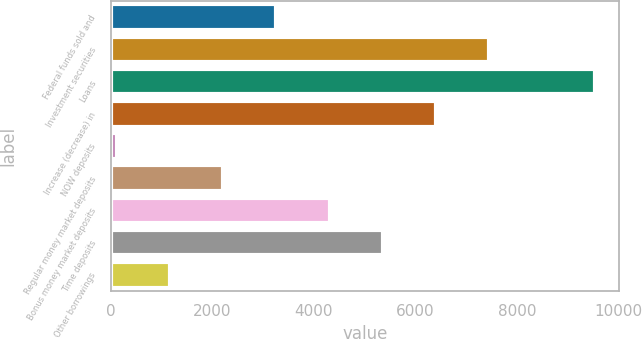Convert chart to OTSL. <chart><loc_0><loc_0><loc_500><loc_500><bar_chart><fcel>Federal funds sold and<fcel>Investment securities<fcel>Loans<fcel>Increase (decrease) in<fcel>NOW deposits<fcel>Regular money market deposits<fcel>Bonus money market deposits<fcel>Time deposits<fcel>Other borrowings<nl><fcel>3258.7<fcel>7450.3<fcel>9546.1<fcel>6402.4<fcel>115<fcel>2210.8<fcel>4306.6<fcel>5354.5<fcel>1162.9<nl></chart> 